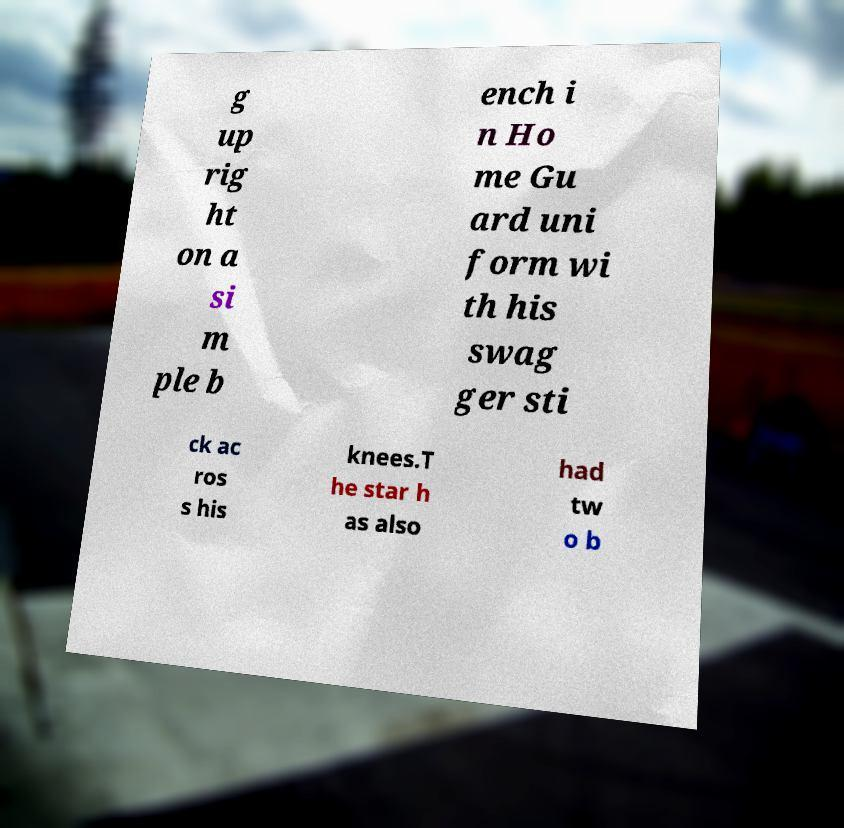There's text embedded in this image that I need extracted. Can you transcribe it verbatim? g up rig ht on a si m ple b ench i n Ho me Gu ard uni form wi th his swag ger sti ck ac ros s his knees.T he star h as also had tw o b 